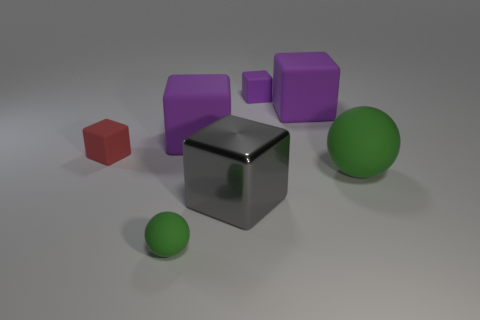Do the small sphere and the big sphere have the same color? yes 